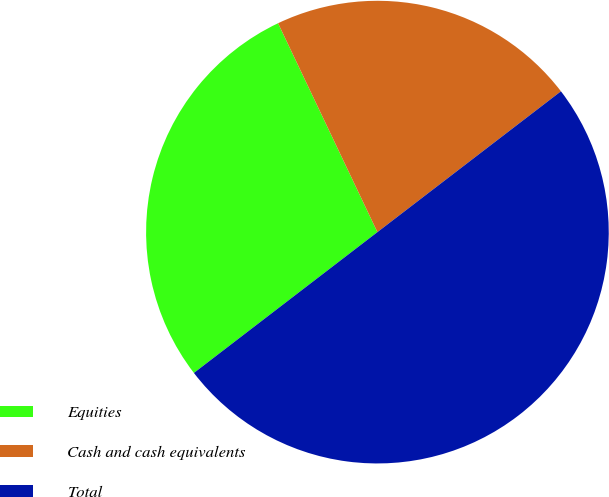<chart> <loc_0><loc_0><loc_500><loc_500><pie_chart><fcel>Equities<fcel>Cash and cash equivalents<fcel>Total<nl><fcel>28.35%<fcel>21.65%<fcel>50.0%<nl></chart> 